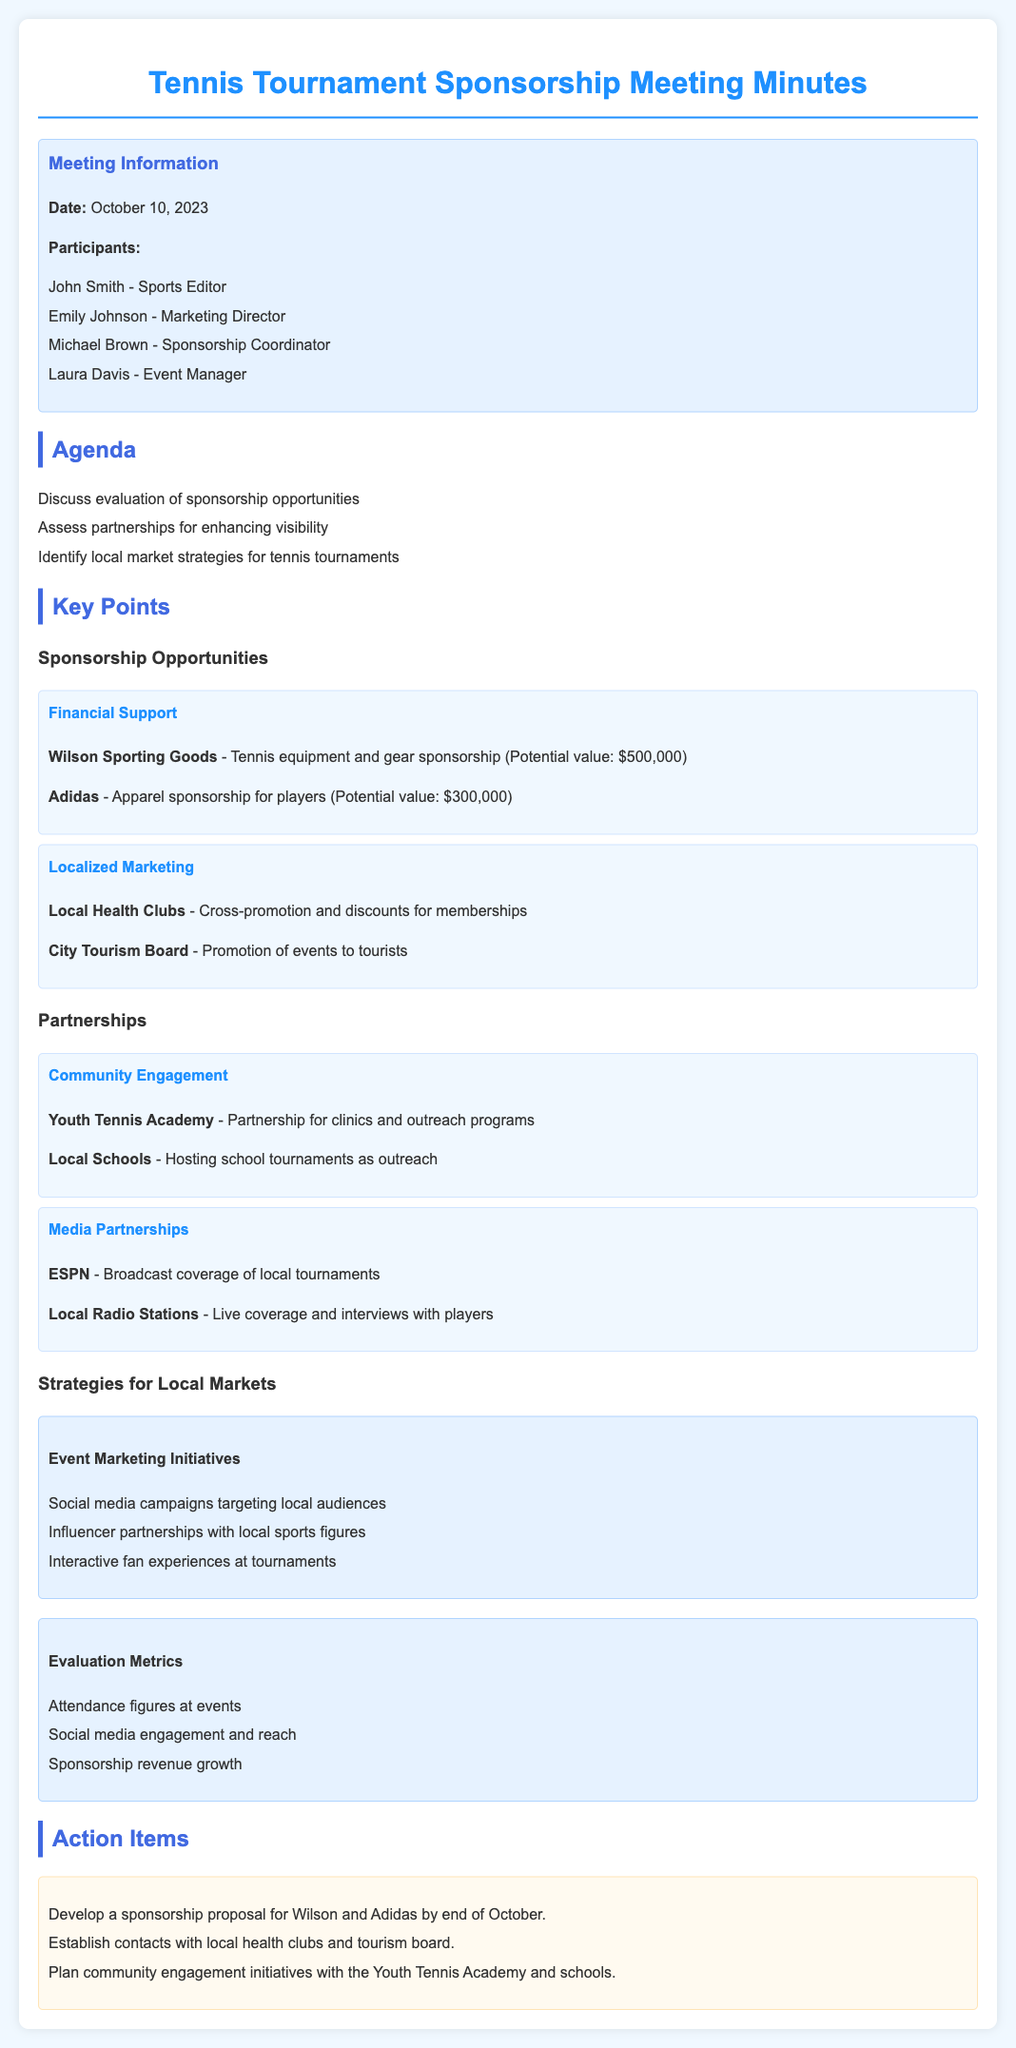What is the date of the meeting? The date of the meeting is specified in the document under "Meeting Information."
Answer: October 10, 2023 Who is the Sports Editor participating in the meeting? The document lists the participants, including their roles.
Answer: John Smith What is the potential value of the Wilson Sporting Goods sponsorship? The potential value is mentioned under the sponsorship opportunities section.
Answer: $500,000 What organization is mentioned for community engagement initiatives? The document outlines specific partnerships for community engagement.
Answer: Youth Tennis Academy Which social media strategy is suggested for local market engagement? The document lists strategies for engaging local markets under event marketing initiatives.
Answer: Social media campaigns targeting local audiences How many action items are listed in the meeting minutes? The document provides a section for action items, detailing the specific tasks.
Answer: Three 